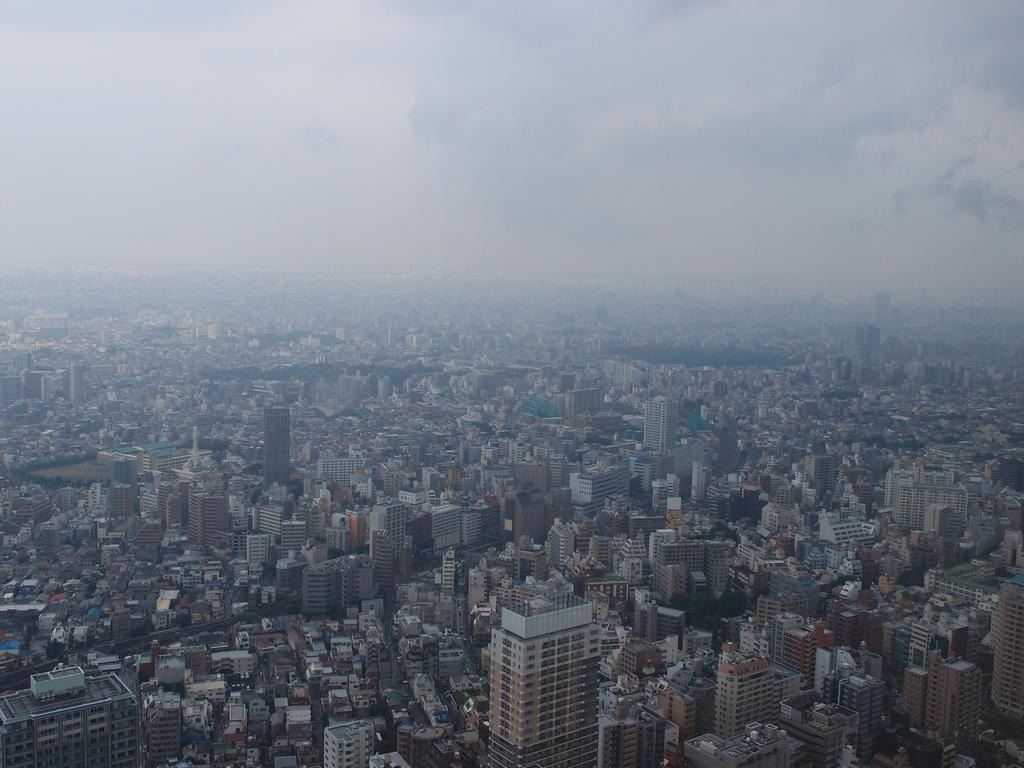What type of structures can be seen in the image? There are buildings in the image. What is visible at the top of the image? The sky is visible at the top of the image. How many books can be seen on the shelves in the image? There are no bookshelves or books present in the image; it only features buildings and the sky. 